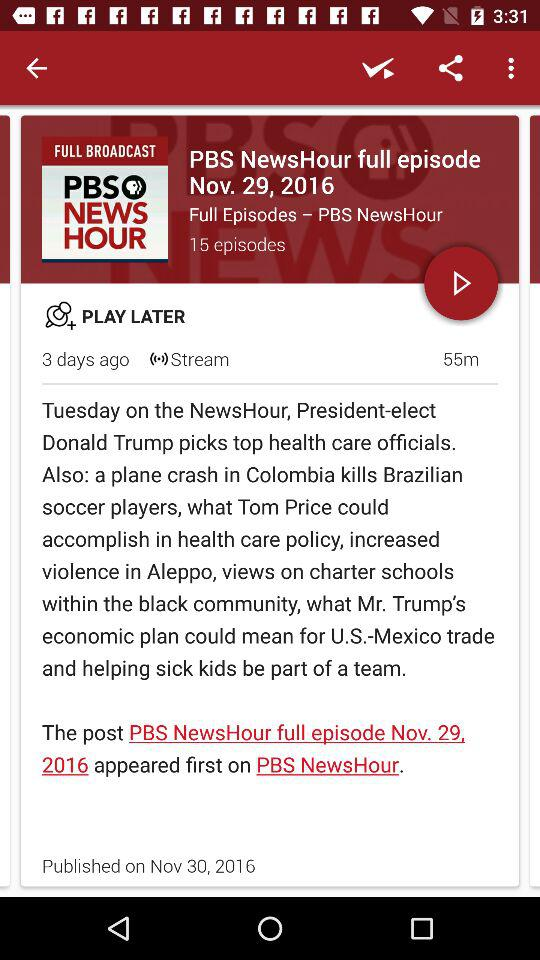How many episodes in total does "PBS NewsHour" contain? There are 15 episodes. 